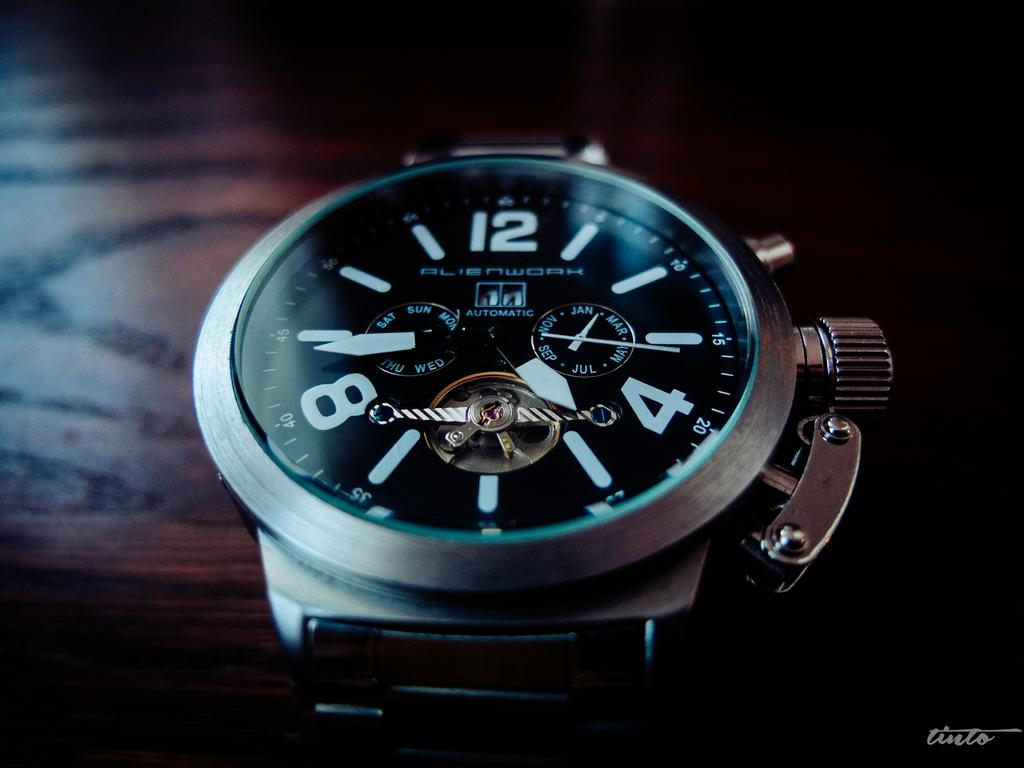<image>
Create a compact narrative representing the image presented. An Alienwork watch on a dark wooden surface 